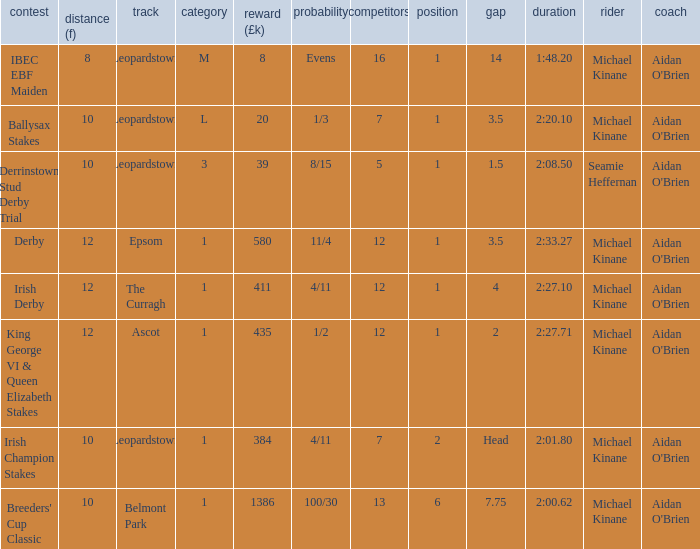Which Margin has a Dist (f) larger than 10, and a Race of king george vi & queen elizabeth stakes? 2.0. 